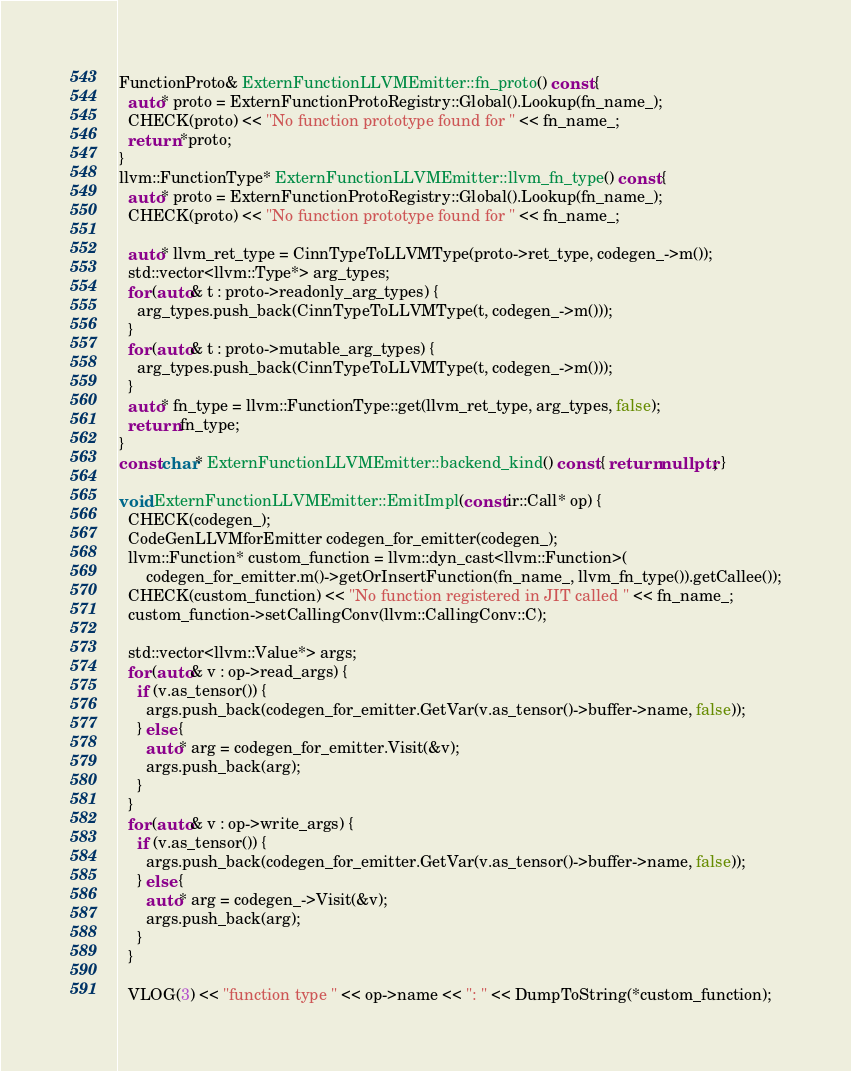Convert code to text. <code><loc_0><loc_0><loc_500><loc_500><_C++_>
FunctionProto& ExternFunctionLLVMEmitter::fn_proto() const {
  auto* proto = ExternFunctionProtoRegistry::Global().Lookup(fn_name_);
  CHECK(proto) << "No function prototype found for " << fn_name_;
  return *proto;
}
llvm::FunctionType* ExternFunctionLLVMEmitter::llvm_fn_type() const {
  auto* proto = ExternFunctionProtoRegistry::Global().Lookup(fn_name_);
  CHECK(proto) << "No function prototype found for " << fn_name_;

  auto* llvm_ret_type = CinnTypeToLLVMType(proto->ret_type, codegen_->m());
  std::vector<llvm::Type*> arg_types;
  for (auto& t : proto->readonly_arg_types) {
    arg_types.push_back(CinnTypeToLLVMType(t, codegen_->m()));
  }
  for (auto& t : proto->mutable_arg_types) {
    arg_types.push_back(CinnTypeToLLVMType(t, codegen_->m()));
  }
  auto* fn_type = llvm::FunctionType::get(llvm_ret_type, arg_types, false);
  return fn_type;
}
const char* ExternFunctionLLVMEmitter::backend_kind() const { return nullptr; }

void ExternFunctionLLVMEmitter::EmitImpl(const ir::Call* op) {
  CHECK(codegen_);
  CodeGenLLVMforEmitter codegen_for_emitter(codegen_);
  llvm::Function* custom_function = llvm::dyn_cast<llvm::Function>(
      codegen_for_emitter.m()->getOrInsertFunction(fn_name_, llvm_fn_type()).getCallee());
  CHECK(custom_function) << "No function registered in JIT called " << fn_name_;
  custom_function->setCallingConv(llvm::CallingConv::C);

  std::vector<llvm::Value*> args;
  for (auto& v : op->read_args) {
    if (v.as_tensor()) {
      args.push_back(codegen_for_emitter.GetVar(v.as_tensor()->buffer->name, false));
    } else {
      auto* arg = codegen_for_emitter.Visit(&v);
      args.push_back(arg);
    }
  }
  for (auto& v : op->write_args) {
    if (v.as_tensor()) {
      args.push_back(codegen_for_emitter.GetVar(v.as_tensor()->buffer->name, false));
    } else {
      auto* arg = codegen_->Visit(&v);
      args.push_back(arg);
    }
  }

  VLOG(3) << "function type " << op->name << ": " << DumpToString(*custom_function);
</code> 